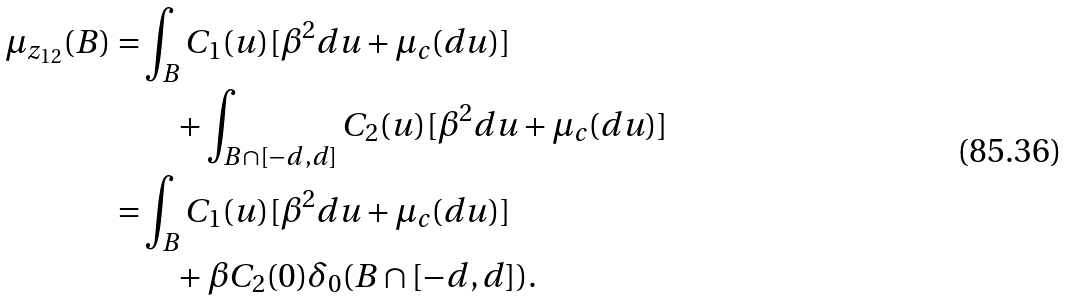<formula> <loc_0><loc_0><loc_500><loc_500>\mu _ { z _ { 1 2 } } ( B ) = & \int _ { B } C _ { 1 } ( u ) [ \beta ^ { 2 } d u + \mu _ { c } ( d u ) ] \\ & \quad + \int _ { B \cap [ - d , d ] } C _ { 2 } ( u ) [ \beta ^ { 2 } d u + \mu _ { c } ( d u ) ] \\ = & \int _ { B } C _ { 1 } ( u ) [ \beta ^ { 2 } d u + \mu _ { c } ( d u ) ] \\ & \quad + \beta C _ { 2 } ( 0 ) \delta _ { 0 } ( B \cap [ - d , d ] ) .</formula> 